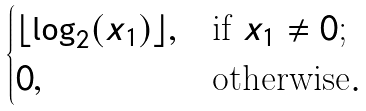Convert formula to latex. <formula><loc_0><loc_0><loc_500><loc_500>\begin{cases} \lfloor \log _ { 2 } ( x _ { 1 } ) \rfloor , & \text {if $x_{1} \neq 0$;} \\ 0 , & \text {otherwise} . \end{cases}</formula> 